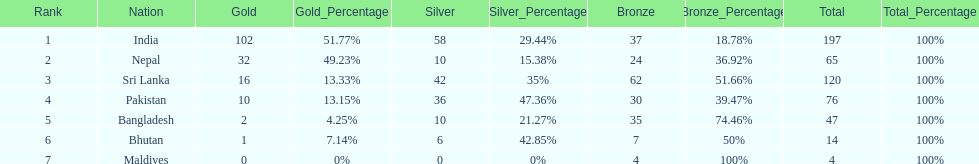How many more gold medals has nepal won than pakistan? 22. Could you parse the entire table as a dict? {'header': ['Rank', 'Nation', 'Gold', 'Gold_Percentage', 'Silver', 'Silver_Percentage', 'Bronze', 'Bronze_Percentage', 'Total', 'Total_Percentage'], 'rows': [['1', 'India', '102', '51.77%', '58', '29.44%', '37', '18.78%', '197', '100%'], ['2', 'Nepal', '32', '49.23%', '10', '15.38%', '24', '36.92%', '65', '100%'], ['3', 'Sri Lanka', '16', '13.33%', '42', '35%', '62', '51.66%', '120', '100%'], ['4', 'Pakistan', '10', '13.15%', '36', '47.36%', '30', '39.47%', '76', '100%'], ['5', 'Bangladesh', '2', '4.25%', '10', '21.27%', '35', '74.46%', '47', '100%'], ['6', 'Bhutan', '1', '7.14%', '6', '42.85%', '7', '50%', '14', '100%'], ['7', 'Maldives', '0', '0%', '0', '0%', '4', '100%', '4', '100%']]} 